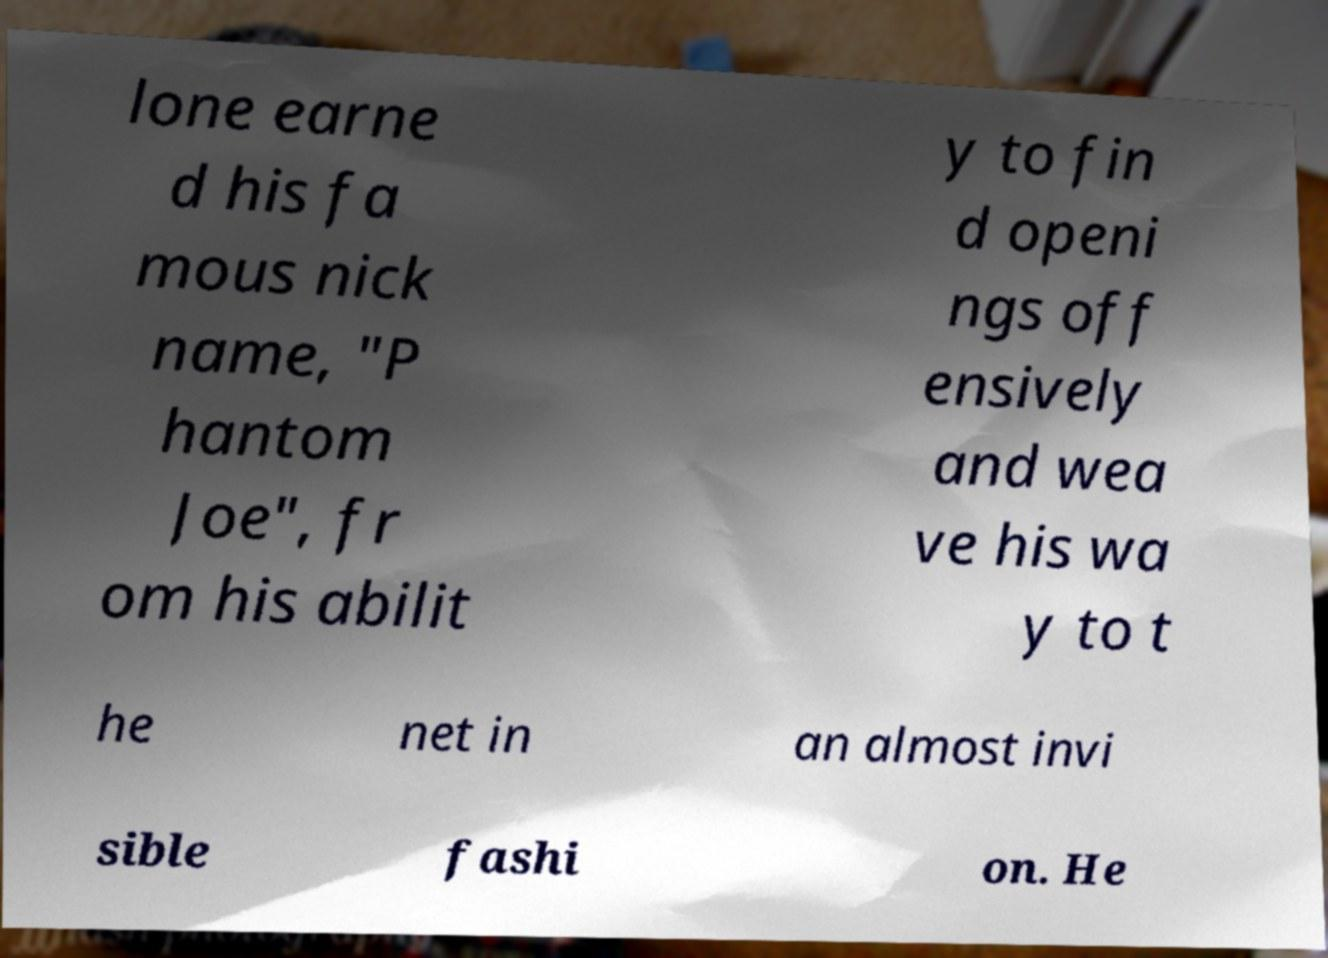There's text embedded in this image that I need extracted. Can you transcribe it verbatim? lone earne d his fa mous nick name, "P hantom Joe", fr om his abilit y to fin d openi ngs off ensively and wea ve his wa y to t he net in an almost invi sible fashi on. He 